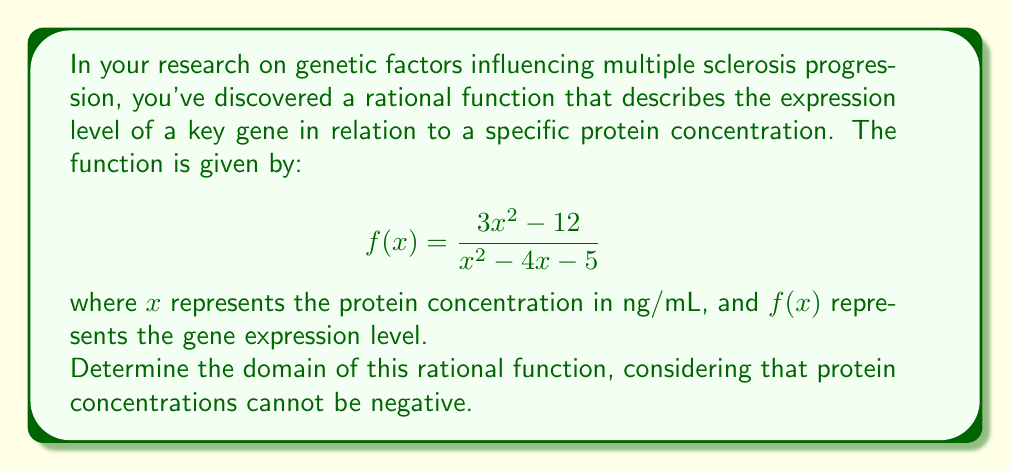Can you solve this math problem? To determine the domain of this rational function, we need to follow these steps:

1) First, consider the general domain restriction for rational functions: the denominator cannot be zero. Set the denominator equal to zero and solve for x:

   $$x^2 - 4x - 5 = 0$$

   This is a quadratic equation. We can solve it using the quadratic formula:
   $$x = \frac{-b \pm \sqrt{b^2 - 4ac}}{2a}$$

   Where $a=1$, $b=-4$, and $c=-5$

   $$x = \frac{4 \pm \sqrt{16 + 20}}{2} = \frac{4 \pm \sqrt{36}}{2} = \frac{4 \pm 6}{2}$$

   $$x = 5 \text{ or } x = -1$$

2) These values of x make the denominator zero, so they must be excluded from the domain.

3) Next, consider the biological context. Protein concentrations cannot be negative, so we must restrict the domain to non-negative values: $x \geq 0$

4) Combining these restrictions, we can express the domain as:

   $$\{x | x \geq 0 \text{ and } x \neq 5\}$$

   In interval notation, this is written as $[0,5) \cup (5,\infty)$
Answer: $[0,5) \cup (5,\infty)$ 